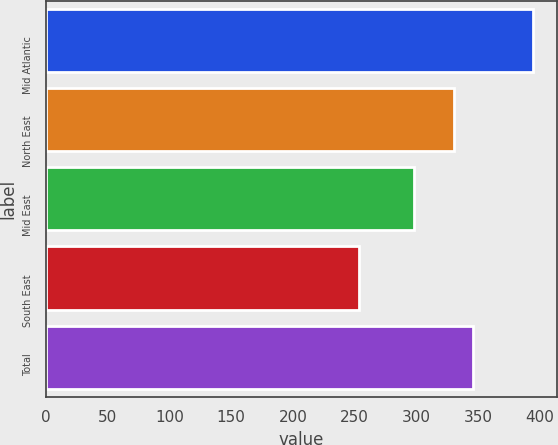Convert chart. <chart><loc_0><loc_0><loc_500><loc_500><bar_chart><fcel>Mid Atlantic<fcel>North East<fcel>Mid East<fcel>South East<fcel>Total<nl><fcel>394.2<fcel>330.2<fcel>297.8<fcel>253.4<fcel>346.2<nl></chart> 